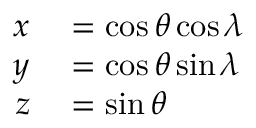<formula> <loc_0><loc_0><loc_500><loc_500>\begin{array} { r l } { x } & = \cos \theta \cos \lambda } \\ { y } & = \cos \theta \sin \lambda } \\ { z } & = \sin \theta } \end{array}</formula> 